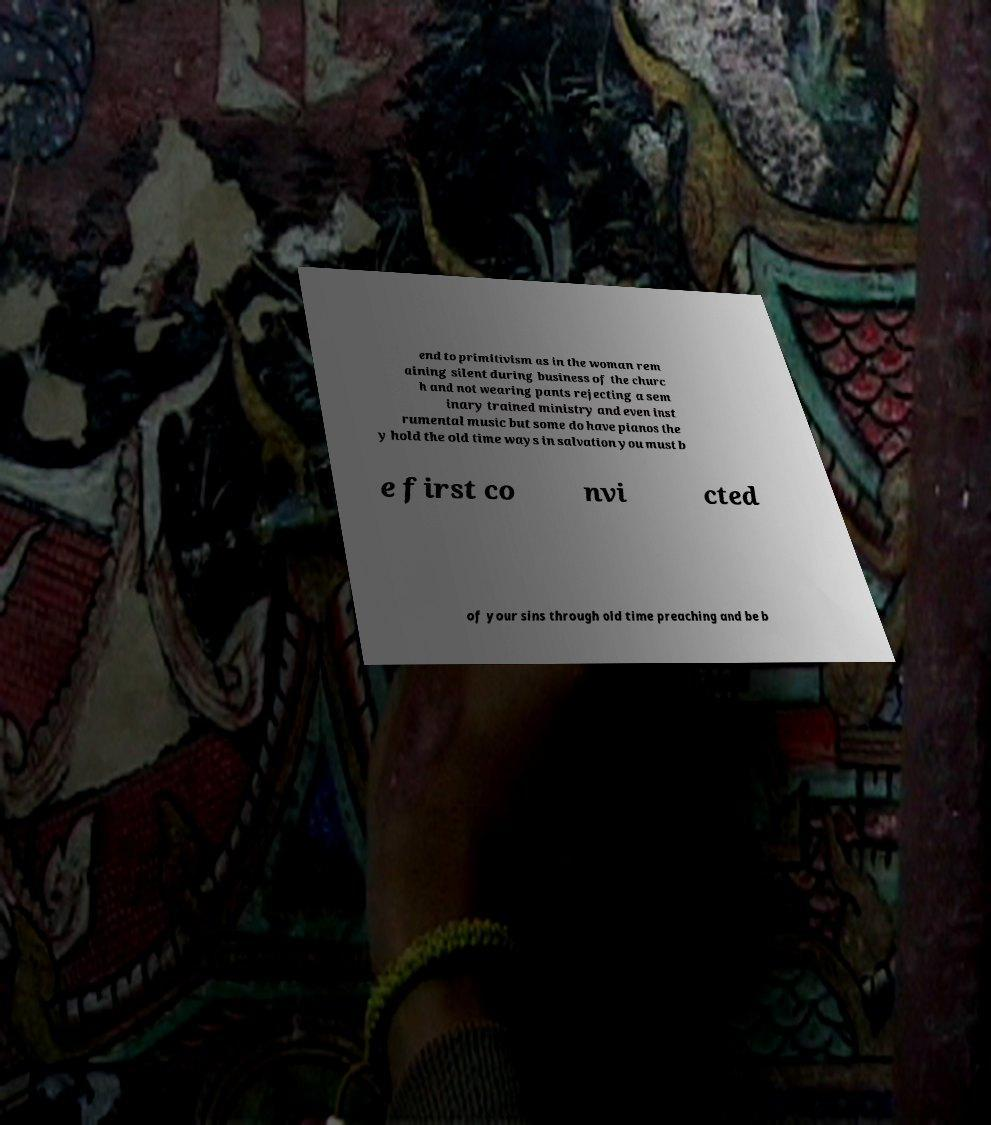I need the written content from this picture converted into text. Can you do that? end to primitivism as in the woman rem aining silent during business of the churc h and not wearing pants rejecting a sem inary trained ministry and even inst rumental music but some do have pianos the y hold the old time ways in salvation you must b e first co nvi cted of your sins through old time preaching and be b 